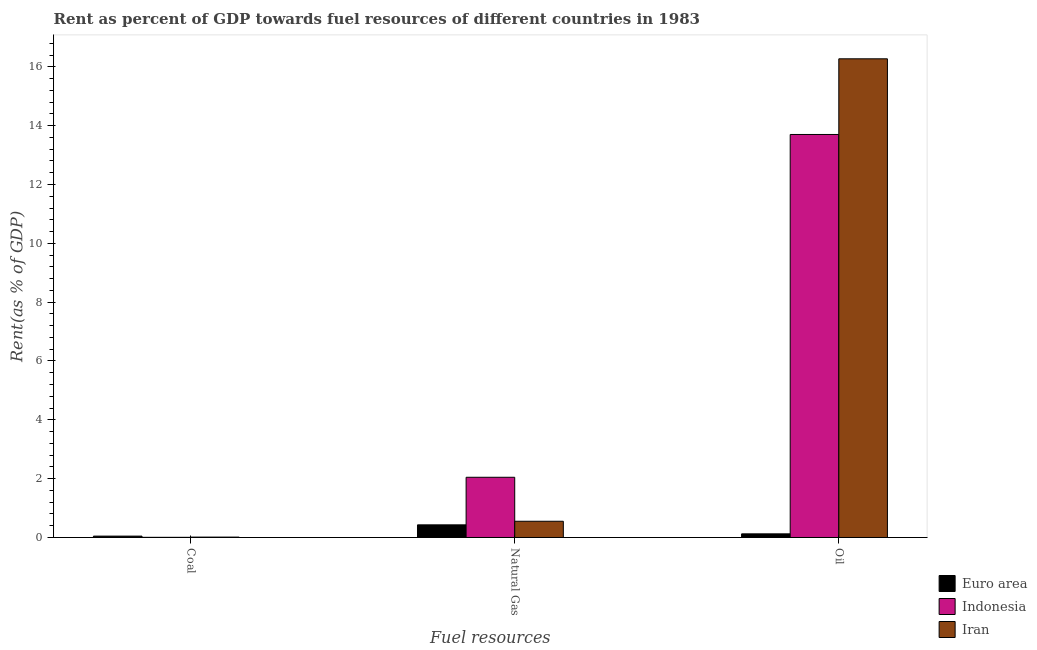How many different coloured bars are there?
Provide a short and direct response. 3. Are the number of bars per tick equal to the number of legend labels?
Provide a succinct answer. Yes. How many bars are there on the 3rd tick from the left?
Ensure brevity in your answer.  3. How many bars are there on the 1st tick from the right?
Your answer should be compact. 3. What is the label of the 1st group of bars from the left?
Provide a short and direct response. Coal. What is the rent towards coal in Euro area?
Keep it short and to the point. 0.05. Across all countries, what is the maximum rent towards coal?
Provide a short and direct response. 0.05. Across all countries, what is the minimum rent towards coal?
Ensure brevity in your answer.  0.01. In which country was the rent towards coal minimum?
Provide a short and direct response. Indonesia. What is the total rent towards coal in the graph?
Offer a terse response. 0.07. What is the difference between the rent towards natural gas in Euro area and that in Indonesia?
Offer a very short reply. -1.62. What is the difference between the rent towards coal in Euro area and the rent towards oil in Iran?
Make the answer very short. -16.23. What is the average rent towards coal per country?
Offer a very short reply. 0.02. What is the difference between the rent towards coal and rent towards natural gas in Euro area?
Give a very brief answer. -0.38. In how many countries, is the rent towards coal greater than 9.6 %?
Offer a very short reply. 0. What is the ratio of the rent towards coal in Iran to that in Euro area?
Provide a short and direct response. 0.28. Is the rent towards oil in Iran less than that in Euro area?
Your answer should be compact. No. What is the difference between the highest and the second highest rent towards natural gas?
Provide a succinct answer. 1.5. What is the difference between the highest and the lowest rent towards coal?
Keep it short and to the point. 0.04. In how many countries, is the rent towards coal greater than the average rent towards coal taken over all countries?
Your answer should be compact. 1. Is it the case that in every country, the sum of the rent towards coal and rent towards natural gas is greater than the rent towards oil?
Keep it short and to the point. No. How many bars are there?
Offer a terse response. 9. What is the difference between two consecutive major ticks on the Y-axis?
Your answer should be compact. 2. Does the graph contain any zero values?
Provide a short and direct response. No. How many legend labels are there?
Keep it short and to the point. 3. What is the title of the graph?
Offer a terse response. Rent as percent of GDP towards fuel resources of different countries in 1983. What is the label or title of the X-axis?
Your answer should be very brief. Fuel resources. What is the label or title of the Y-axis?
Your response must be concise. Rent(as % of GDP). What is the Rent(as % of GDP) of Euro area in Coal?
Give a very brief answer. 0.05. What is the Rent(as % of GDP) in Indonesia in Coal?
Offer a terse response. 0.01. What is the Rent(as % of GDP) in Iran in Coal?
Give a very brief answer. 0.01. What is the Rent(as % of GDP) in Euro area in Natural Gas?
Your answer should be compact. 0.43. What is the Rent(as % of GDP) in Indonesia in Natural Gas?
Make the answer very short. 2.05. What is the Rent(as % of GDP) of Iran in Natural Gas?
Your answer should be compact. 0.55. What is the Rent(as % of GDP) in Euro area in Oil?
Ensure brevity in your answer.  0.12. What is the Rent(as % of GDP) in Indonesia in Oil?
Your answer should be compact. 13.7. What is the Rent(as % of GDP) of Iran in Oil?
Provide a succinct answer. 16.27. Across all Fuel resources, what is the maximum Rent(as % of GDP) in Euro area?
Provide a succinct answer. 0.43. Across all Fuel resources, what is the maximum Rent(as % of GDP) of Indonesia?
Your response must be concise. 13.7. Across all Fuel resources, what is the maximum Rent(as % of GDP) of Iran?
Offer a very short reply. 16.27. Across all Fuel resources, what is the minimum Rent(as % of GDP) of Euro area?
Offer a terse response. 0.05. Across all Fuel resources, what is the minimum Rent(as % of GDP) in Indonesia?
Make the answer very short. 0.01. Across all Fuel resources, what is the minimum Rent(as % of GDP) in Iran?
Make the answer very short. 0.01. What is the total Rent(as % of GDP) of Euro area in the graph?
Your answer should be very brief. 0.6. What is the total Rent(as % of GDP) of Indonesia in the graph?
Ensure brevity in your answer.  15.75. What is the total Rent(as % of GDP) in Iran in the graph?
Provide a short and direct response. 16.84. What is the difference between the Rent(as % of GDP) of Euro area in Coal and that in Natural Gas?
Provide a short and direct response. -0.38. What is the difference between the Rent(as % of GDP) of Indonesia in Coal and that in Natural Gas?
Offer a terse response. -2.04. What is the difference between the Rent(as % of GDP) in Iran in Coal and that in Natural Gas?
Your answer should be compact. -0.54. What is the difference between the Rent(as % of GDP) of Euro area in Coal and that in Oil?
Offer a very short reply. -0.08. What is the difference between the Rent(as % of GDP) of Indonesia in Coal and that in Oil?
Ensure brevity in your answer.  -13.7. What is the difference between the Rent(as % of GDP) in Iran in Coal and that in Oil?
Ensure brevity in your answer.  -16.26. What is the difference between the Rent(as % of GDP) of Euro area in Natural Gas and that in Oil?
Keep it short and to the point. 0.31. What is the difference between the Rent(as % of GDP) of Indonesia in Natural Gas and that in Oil?
Offer a terse response. -11.65. What is the difference between the Rent(as % of GDP) in Iran in Natural Gas and that in Oil?
Make the answer very short. -15.72. What is the difference between the Rent(as % of GDP) of Euro area in Coal and the Rent(as % of GDP) of Indonesia in Natural Gas?
Keep it short and to the point. -2. What is the difference between the Rent(as % of GDP) of Euro area in Coal and the Rent(as % of GDP) of Iran in Natural Gas?
Make the answer very short. -0.51. What is the difference between the Rent(as % of GDP) of Indonesia in Coal and the Rent(as % of GDP) of Iran in Natural Gas?
Provide a short and direct response. -0.55. What is the difference between the Rent(as % of GDP) in Euro area in Coal and the Rent(as % of GDP) in Indonesia in Oil?
Make the answer very short. -13.65. What is the difference between the Rent(as % of GDP) of Euro area in Coal and the Rent(as % of GDP) of Iran in Oil?
Make the answer very short. -16.23. What is the difference between the Rent(as % of GDP) in Indonesia in Coal and the Rent(as % of GDP) in Iran in Oil?
Offer a very short reply. -16.27. What is the difference between the Rent(as % of GDP) in Euro area in Natural Gas and the Rent(as % of GDP) in Indonesia in Oil?
Your answer should be very brief. -13.27. What is the difference between the Rent(as % of GDP) in Euro area in Natural Gas and the Rent(as % of GDP) in Iran in Oil?
Keep it short and to the point. -15.84. What is the difference between the Rent(as % of GDP) of Indonesia in Natural Gas and the Rent(as % of GDP) of Iran in Oil?
Your response must be concise. -14.23. What is the average Rent(as % of GDP) of Indonesia per Fuel resources?
Your answer should be very brief. 5.25. What is the average Rent(as % of GDP) of Iran per Fuel resources?
Your answer should be very brief. 5.61. What is the difference between the Rent(as % of GDP) of Euro area and Rent(as % of GDP) of Indonesia in Coal?
Offer a very short reply. 0.04. What is the difference between the Rent(as % of GDP) of Euro area and Rent(as % of GDP) of Iran in Coal?
Provide a succinct answer. 0.03. What is the difference between the Rent(as % of GDP) in Indonesia and Rent(as % of GDP) in Iran in Coal?
Ensure brevity in your answer.  -0.01. What is the difference between the Rent(as % of GDP) in Euro area and Rent(as % of GDP) in Indonesia in Natural Gas?
Make the answer very short. -1.62. What is the difference between the Rent(as % of GDP) in Euro area and Rent(as % of GDP) in Iran in Natural Gas?
Give a very brief answer. -0.12. What is the difference between the Rent(as % of GDP) of Indonesia and Rent(as % of GDP) of Iran in Natural Gas?
Ensure brevity in your answer.  1.5. What is the difference between the Rent(as % of GDP) of Euro area and Rent(as % of GDP) of Indonesia in Oil?
Ensure brevity in your answer.  -13.58. What is the difference between the Rent(as % of GDP) in Euro area and Rent(as % of GDP) in Iran in Oil?
Ensure brevity in your answer.  -16.15. What is the difference between the Rent(as % of GDP) in Indonesia and Rent(as % of GDP) in Iran in Oil?
Your response must be concise. -2.57. What is the ratio of the Rent(as % of GDP) in Euro area in Coal to that in Natural Gas?
Keep it short and to the point. 0.11. What is the ratio of the Rent(as % of GDP) of Indonesia in Coal to that in Natural Gas?
Your response must be concise. 0. What is the ratio of the Rent(as % of GDP) in Iran in Coal to that in Natural Gas?
Keep it short and to the point. 0.02. What is the ratio of the Rent(as % of GDP) of Euro area in Coal to that in Oil?
Offer a very short reply. 0.38. What is the ratio of the Rent(as % of GDP) of Iran in Coal to that in Oil?
Your answer should be compact. 0. What is the ratio of the Rent(as % of GDP) in Euro area in Natural Gas to that in Oil?
Your answer should be compact. 3.47. What is the ratio of the Rent(as % of GDP) in Indonesia in Natural Gas to that in Oil?
Provide a short and direct response. 0.15. What is the ratio of the Rent(as % of GDP) in Iran in Natural Gas to that in Oil?
Your response must be concise. 0.03. What is the difference between the highest and the second highest Rent(as % of GDP) in Euro area?
Ensure brevity in your answer.  0.31. What is the difference between the highest and the second highest Rent(as % of GDP) in Indonesia?
Offer a terse response. 11.65. What is the difference between the highest and the second highest Rent(as % of GDP) of Iran?
Make the answer very short. 15.72. What is the difference between the highest and the lowest Rent(as % of GDP) of Euro area?
Your response must be concise. 0.38. What is the difference between the highest and the lowest Rent(as % of GDP) of Indonesia?
Your answer should be compact. 13.7. What is the difference between the highest and the lowest Rent(as % of GDP) of Iran?
Provide a succinct answer. 16.26. 